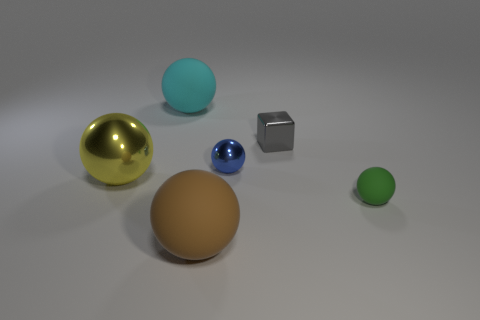Subtract all cyan spheres. How many spheres are left? 4 Subtract all cyan spheres. How many spheres are left? 4 Subtract 2 balls. How many balls are left? 3 Subtract all red balls. Subtract all gray cylinders. How many balls are left? 5 Add 2 tiny cyan matte blocks. How many objects exist? 8 Subtract all cubes. How many objects are left? 5 Subtract 0 gray cylinders. How many objects are left? 6 Subtract all small spheres. Subtract all matte spheres. How many objects are left? 1 Add 1 large metallic spheres. How many large metallic spheres are left? 2 Add 2 cyan objects. How many cyan objects exist? 3 